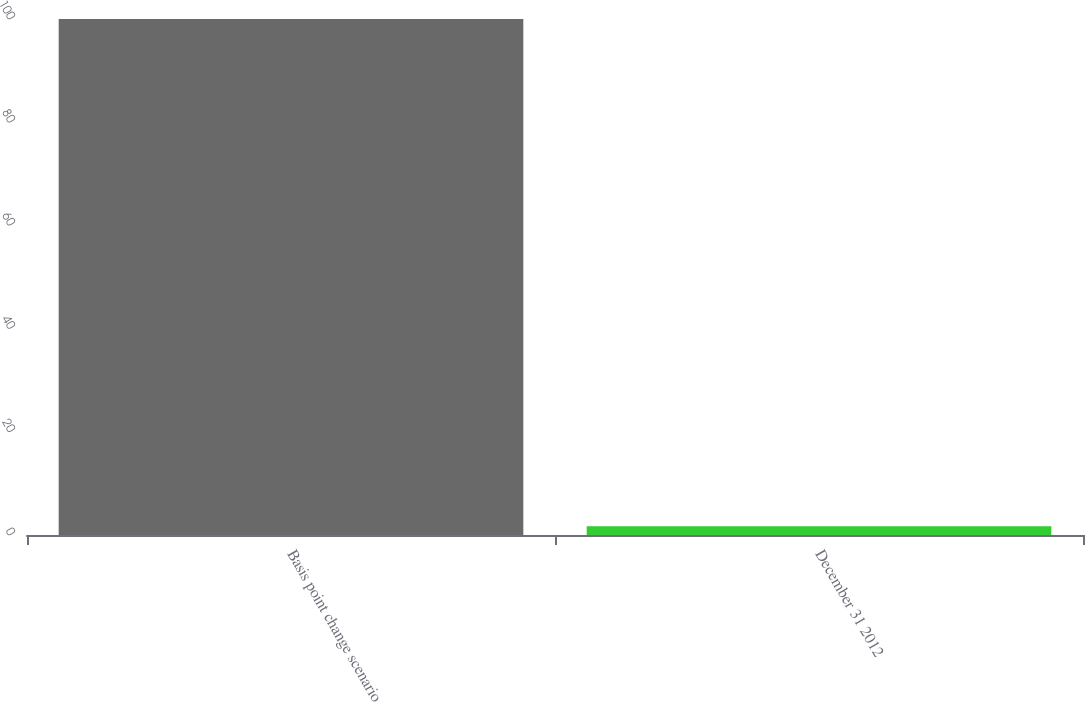Convert chart. <chart><loc_0><loc_0><loc_500><loc_500><bar_chart><fcel>Basis point change scenario<fcel>December 31 2012<nl><fcel>100<fcel>1.7<nl></chart> 